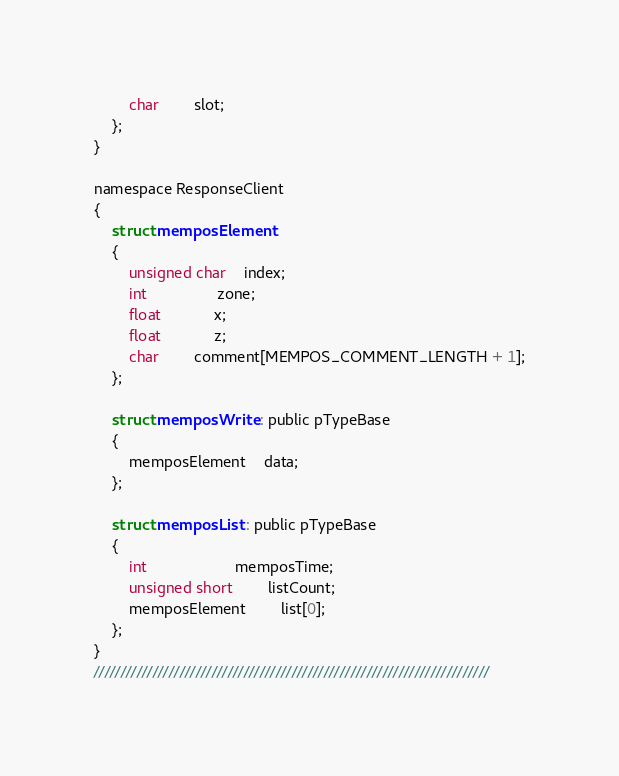Convert code to text. <code><loc_0><loc_0><loc_500><loc_500><_C_>		char		slot;
	};
}

namespace ResponseClient
{
	struct memposElement 
	{
		unsigned char	index;
		int				zone;
		float			x;
		float			z;
		char		comment[MEMPOS_COMMENT_LENGTH + 1];
	};

	struct memposWrite : public pTypeBase 
	{
		memposElement	data;
	};

	struct memposList : public pTypeBase 
	{
		int					memposTime;
		unsigned short		listCount;
		memposElement		list[0];
	};
}
//////////////////////////////////////////////////////////////////////////</code> 